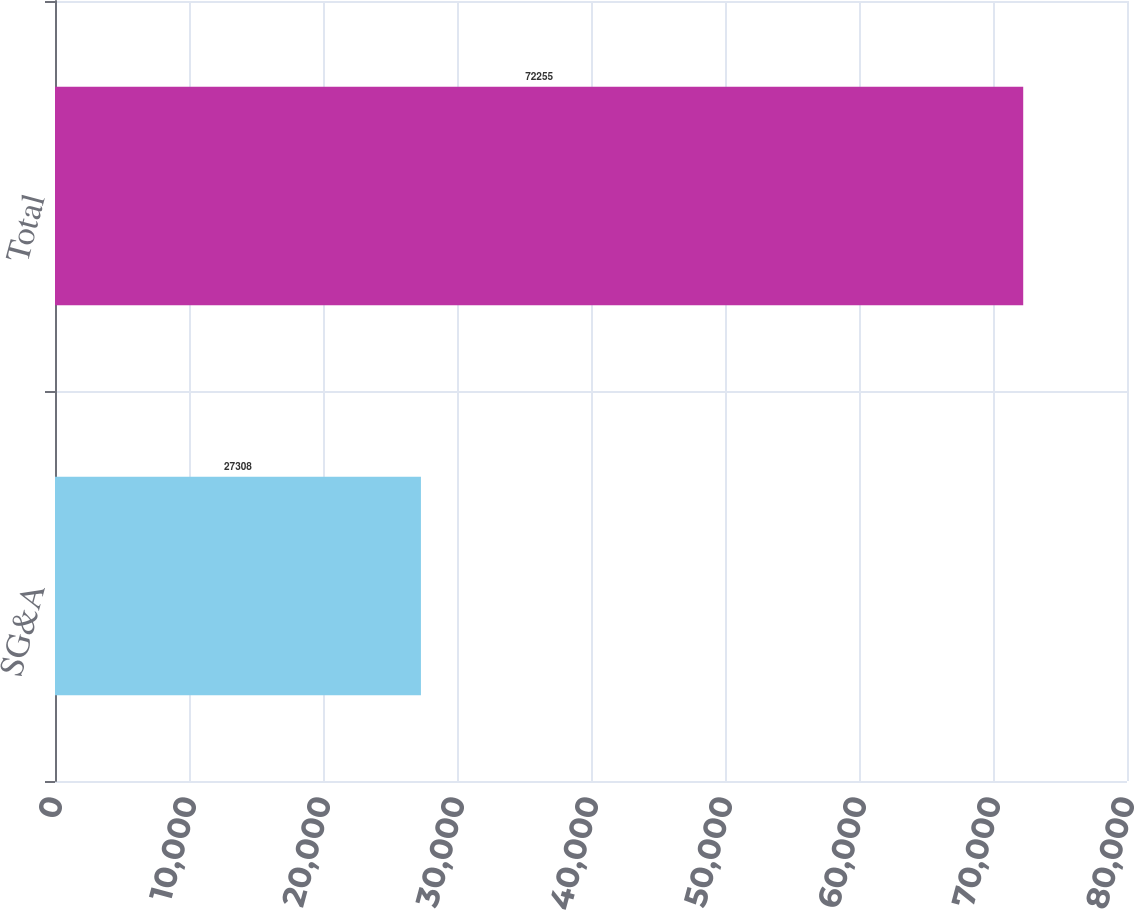<chart> <loc_0><loc_0><loc_500><loc_500><bar_chart><fcel>SG&A<fcel>Total<nl><fcel>27308<fcel>72255<nl></chart> 